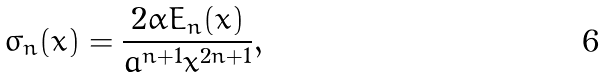<formula> <loc_0><loc_0><loc_500><loc_500>\sigma _ { n } ( x ) = \frac { 2 \alpha E _ { n } ( x ) } { a ^ { n + 1 } x ^ { 2 n + 1 } } ,</formula> 